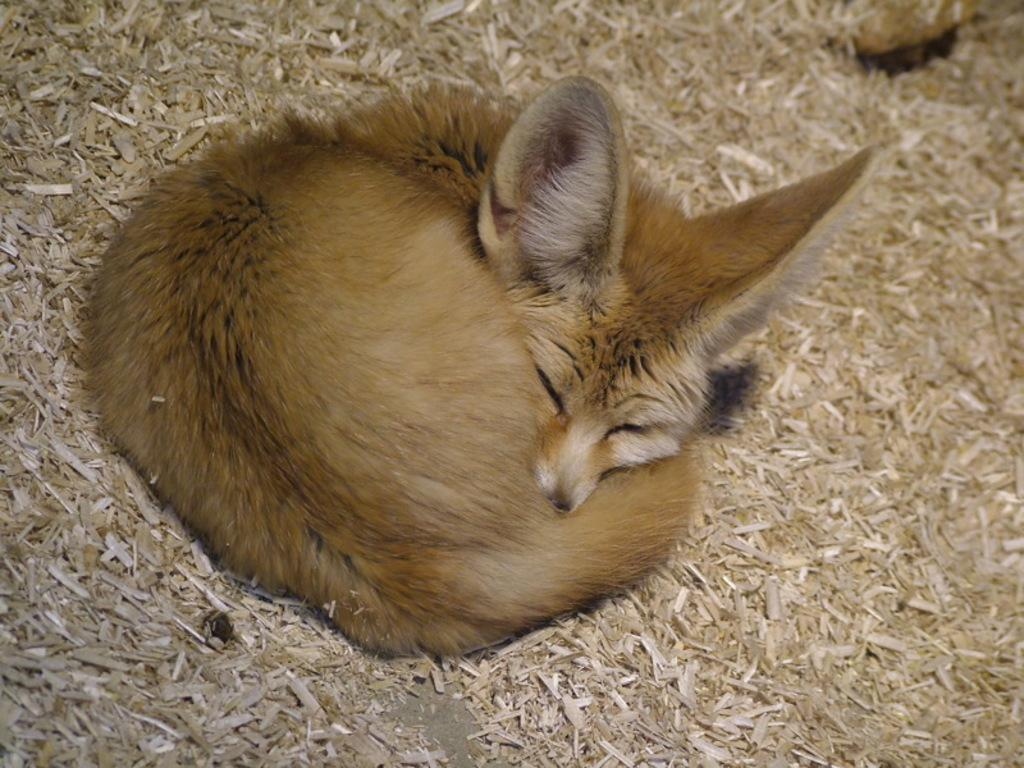What animal can be seen in the image? There is a fox in the image. What is the fox doing in the image? The fox is sleeping. Where is the fox located in the image? The fox is on a dry grassland. How many brushes are being used by the fox in the image? There are no brushes present in the image, as the fox is sleeping on a dry grassland. 